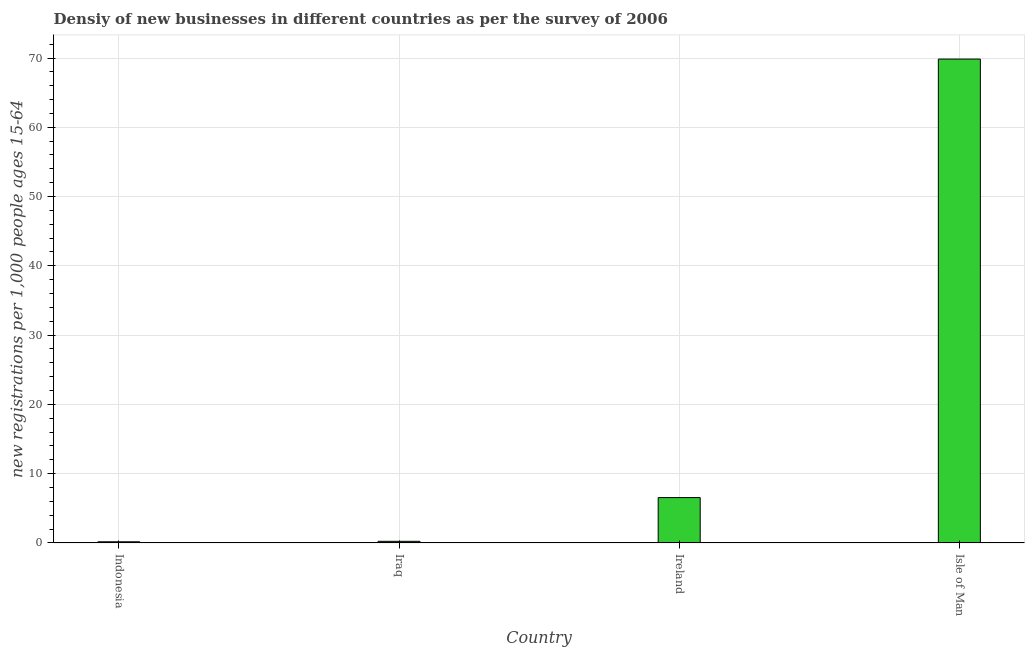What is the title of the graph?
Offer a very short reply. Densiy of new businesses in different countries as per the survey of 2006. What is the label or title of the X-axis?
Provide a short and direct response. Country. What is the label or title of the Y-axis?
Provide a short and direct response. New registrations per 1,0 people ages 15-64. What is the density of new business in Indonesia?
Provide a short and direct response. 0.16. Across all countries, what is the maximum density of new business?
Ensure brevity in your answer.  69.85. Across all countries, what is the minimum density of new business?
Keep it short and to the point. 0.16. In which country was the density of new business maximum?
Make the answer very short. Isle of Man. What is the sum of the density of new business?
Provide a succinct answer. 76.77. What is the difference between the density of new business in Indonesia and Isle of Man?
Your answer should be compact. -69.69. What is the average density of new business per country?
Provide a short and direct response. 19.19. What is the median density of new business?
Ensure brevity in your answer.  3.38. What is the ratio of the density of new business in Iraq to that in Ireland?
Ensure brevity in your answer.  0.03. What is the difference between the highest and the second highest density of new business?
Provide a succinct answer. 63.31. Is the sum of the density of new business in Iraq and Ireland greater than the maximum density of new business across all countries?
Give a very brief answer. No. What is the difference between the highest and the lowest density of new business?
Offer a terse response. 69.69. In how many countries, is the density of new business greater than the average density of new business taken over all countries?
Make the answer very short. 1. How many bars are there?
Provide a short and direct response. 4. How many countries are there in the graph?
Provide a succinct answer. 4. Are the values on the major ticks of Y-axis written in scientific E-notation?
Make the answer very short. No. What is the new registrations per 1,000 people ages 15-64 of Indonesia?
Offer a very short reply. 0.16. What is the new registrations per 1,000 people ages 15-64 of Iraq?
Make the answer very short. 0.23. What is the new registrations per 1,000 people ages 15-64 in Ireland?
Your answer should be compact. 6.54. What is the new registrations per 1,000 people ages 15-64 of Isle of Man?
Your response must be concise. 69.85. What is the difference between the new registrations per 1,000 people ages 15-64 in Indonesia and Iraq?
Provide a short and direct response. -0.07. What is the difference between the new registrations per 1,000 people ages 15-64 in Indonesia and Ireland?
Provide a succinct answer. -6.38. What is the difference between the new registrations per 1,000 people ages 15-64 in Indonesia and Isle of Man?
Offer a terse response. -69.69. What is the difference between the new registrations per 1,000 people ages 15-64 in Iraq and Ireland?
Provide a succinct answer. -6.32. What is the difference between the new registrations per 1,000 people ages 15-64 in Iraq and Isle of Man?
Give a very brief answer. -69.62. What is the difference between the new registrations per 1,000 people ages 15-64 in Ireland and Isle of Man?
Your answer should be compact. -63.31. What is the ratio of the new registrations per 1,000 people ages 15-64 in Indonesia to that in Iraq?
Give a very brief answer. 0.71. What is the ratio of the new registrations per 1,000 people ages 15-64 in Indonesia to that in Ireland?
Provide a short and direct response. 0.02. What is the ratio of the new registrations per 1,000 people ages 15-64 in Indonesia to that in Isle of Man?
Ensure brevity in your answer.  0. What is the ratio of the new registrations per 1,000 people ages 15-64 in Iraq to that in Ireland?
Provide a succinct answer. 0.03. What is the ratio of the new registrations per 1,000 people ages 15-64 in Iraq to that in Isle of Man?
Provide a short and direct response. 0. What is the ratio of the new registrations per 1,000 people ages 15-64 in Ireland to that in Isle of Man?
Give a very brief answer. 0.09. 